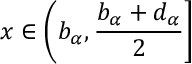Convert formula to latex. <formula><loc_0><loc_0><loc_500><loc_500>x \in \left ( b _ { \alpha } , \frac { b _ { \alpha } + d _ { \alpha } } { 2 } \right ]</formula> 